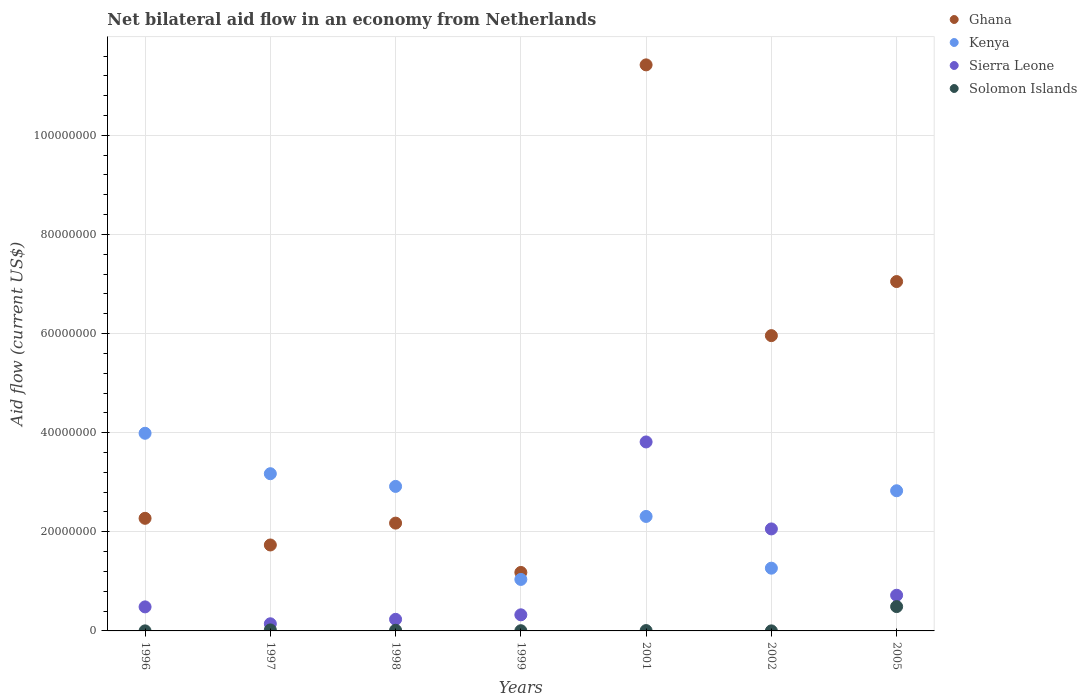How many different coloured dotlines are there?
Provide a short and direct response. 4. Is the number of dotlines equal to the number of legend labels?
Your answer should be very brief. Yes. What is the net bilateral aid flow in Ghana in 1999?
Your response must be concise. 1.18e+07. Across all years, what is the maximum net bilateral aid flow in Ghana?
Ensure brevity in your answer.  1.14e+08. Across all years, what is the minimum net bilateral aid flow in Sierra Leone?
Give a very brief answer. 1.44e+06. In which year was the net bilateral aid flow in Ghana maximum?
Your answer should be compact. 2001. In which year was the net bilateral aid flow in Solomon Islands minimum?
Make the answer very short. 1996. What is the total net bilateral aid flow in Solomon Islands in the graph?
Offer a terse response. 5.37e+06. What is the difference between the net bilateral aid flow in Ghana in 1996 and that in 2002?
Provide a succinct answer. -3.69e+07. What is the difference between the net bilateral aid flow in Ghana in 1998 and the net bilateral aid flow in Kenya in 1997?
Offer a very short reply. -9.97e+06. What is the average net bilateral aid flow in Solomon Islands per year?
Your answer should be very brief. 7.67e+05. In the year 2005, what is the difference between the net bilateral aid flow in Sierra Leone and net bilateral aid flow in Solomon Islands?
Give a very brief answer. 2.29e+06. In how many years, is the net bilateral aid flow in Sierra Leone greater than 40000000 US$?
Make the answer very short. 0. What is the ratio of the net bilateral aid flow in Sierra Leone in 1998 to that in 1999?
Your response must be concise. 0.72. What is the difference between the highest and the second highest net bilateral aid flow in Sierra Leone?
Provide a succinct answer. 1.76e+07. What is the difference between the highest and the lowest net bilateral aid flow in Solomon Islands?
Your answer should be very brief. 4.90e+06. Does the net bilateral aid flow in Kenya monotonically increase over the years?
Offer a very short reply. No. Is the net bilateral aid flow in Kenya strictly less than the net bilateral aid flow in Solomon Islands over the years?
Your response must be concise. No. How many dotlines are there?
Your answer should be very brief. 4. How many years are there in the graph?
Offer a terse response. 7. What is the difference between two consecutive major ticks on the Y-axis?
Keep it short and to the point. 2.00e+07. Are the values on the major ticks of Y-axis written in scientific E-notation?
Provide a succinct answer. No. Does the graph contain any zero values?
Your response must be concise. No. What is the title of the graph?
Ensure brevity in your answer.  Net bilateral aid flow in an economy from Netherlands. What is the label or title of the X-axis?
Your answer should be compact. Years. What is the Aid flow (current US$) of Ghana in 1996?
Ensure brevity in your answer.  2.27e+07. What is the Aid flow (current US$) of Kenya in 1996?
Keep it short and to the point. 3.99e+07. What is the Aid flow (current US$) in Sierra Leone in 1996?
Ensure brevity in your answer.  4.85e+06. What is the Aid flow (current US$) in Solomon Islands in 1996?
Provide a short and direct response. 10000. What is the Aid flow (current US$) of Ghana in 1997?
Your response must be concise. 1.73e+07. What is the Aid flow (current US$) in Kenya in 1997?
Offer a very short reply. 3.17e+07. What is the Aid flow (current US$) of Sierra Leone in 1997?
Provide a short and direct response. 1.44e+06. What is the Aid flow (current US$) in Ghana in 1998?
Your response must be concise. 2.18e+07. What is the Aid flow (current US$) in Kenya in 1998?
Provide a short and direct response. 2.92e+07. What is the Aid flow (current US$) of Sierra Leone in 1998?
Offer a very short reply. 2.34e+06. What is the Aid flow (current US$) of Solomon Islands in 1998?
Provide a short and direct response. 1.30e+05. What is the Aid flow (current US$) in Ghana in 1999?
Make the answer very short. 1.18e+07. What is the Aid flow (current US$) in Kenya in 1999?
Give a very brief answer. 1.04e+07. What is the Aid flow (current US$) in Sierra Leone in 1999?
Make the answer very short. 3.25e+06. What is the Aid flow (current US$) of Solomon Islands in 1999?
Give a very brief answer. 4.00e+04. What is the Aid flow (current US$) in Ghana in 2001?
Your answer should be compact. 1.14e+08. What is the Aid flow (current US$) of Kenya in 2001?
Give a very brief answer. 2.31e+07. What is the Aid flow (current US$) of Sierra Leone in 2001?
Give a very brief answer. 3.81e+07. What is the Aid flow (current US$) in Solomon Islands in 2001?
Make the answer very short. 7.00e+04. What is the Aid flow (current US$) of Ghana in 2002?
Offer a terse response. 5.96e+07. What is the Aid flow (current US$) of Kenya in 2002?
Your response must be concise. 1.27e+07. What is the Aid flow (current US$) of Sierra Leone in 2002?
Your answer should be very brief. 2.06e+07. What is the Aid flow (current US$) in Ghana in 2005?
Ensure brevity in your answer.  7.05e+07. What is the Aid flow (current US$) of Kenya in 2005?
Offer a terse response. 2.83e+07. What is the Aid flow (current US$) in Sierra Leone in 2005?
Offer a very short reply. 7.20e+06. What is the Aid flow (current US$) in Solomon Islands in 2005?
Offer a very short reply. 4.91e+06. Across all years, what is the maximum Aid flow (current US$) in Ghana?
Offer a very short reply. 1.14e+08. Across all years, what is the maximum Aid flow (current US$) of Kenya?
Your response must be concise. 3.99e+07. Across all years, what is the maximum Aid flow (current US$) in Sierra Leone?
Provide a succinct answer. 3.81e+07. Across all years, what is the maximum Aid flow (current US$) of Solomon Islands?
Offer a terse response. 4.91e+06. Across all years, what is the minimum Aid flow (current US$) in Ghana?
Offer a very short reply. 1.18e+07. Across all years, what is the minimum Aid flow (current US$) in Kenya?
Offer a terse response. 1.04e+07. Across all years, what is the minimum Aid flow (current US$) of Sierra Leone?
Offer a very short reply. 1.44e+06. Across all years, what is the minimum Aid flow (current US$) in Solomon Islands?
Keep it short and to the point. 10000. What is the total Aid flow (current US$) in Ghana in the graph?
Your response must be concise. 3.18e+08. What is the total Aid flow (current US$) in Kenya in the graph?
Give a very brief answer. 1.75e+08. What is the total Aid flow (current US$) in Sierra Leone in the graph?
Your response must be concise. 7.78e+07. What is the total Aid flow (current US$) of Solomon Islands in the graph?
Your answer should be compact. 5.37e+06. What is the difference between the Aid flow (current US$) in Ghana in 1996 and that in 1997?
Your answer should be very brief. 5.38e+06. What is the difference between the Aid flow (current US$) in Kenya in 1996 and that in 1997?
Provide a short and direct response. 8.16e+06. What is the difference between the Aid flow (current US$) in Sierra Leone in 1996 and that in 1997?
Your answer should be very brief. 3.41e+06. What is the difference between the Aid flow (current US$) of Solomon Islands in 1996 and that in 1997?
Provide a short and direct response. -1.90e+05. What is the difference between the Aid flow (current US$) in Ghana in 1996 and that in 1998?
Give a very brief answer. 9.70e+05. What is the difference between the Aid flow (current US$) of Kenya in 1996 and that in 1998?
Make the answer very short. 1.07e+07. What is the difference between the Aid flow (current US$) in Sierra Leone in 1996 and that in 1998?
Offer a very short reply. 2.51e+06. What is the difference between the Aid flow (current US$) of Solomon Islands in 1996 and that in 1998?
Your answer should be compact. -1.20e+05. What is the difference between the Aid flow (current US$) in Ghana in 1996 and that in 1999?
Your response must be concise. 1.09e+07. What is the difference between the Aid flow (current US$) in Kenya in 1996 and that in 1999?
Keep it short and to the point. 2.95e+07. What is the difference between the Aid flow (current US$) of Sierra Leone in 1996 and that in 1999?
Offer a very short reply. 1.60e+06. What is the difference between the Aid flow (current US$) in Solomon Islands in 1996 and that in 1999?
Offer a terse response. -3.00e+04. What is the difference between the Aid flow (current US$) in Ghana in 1996 and that in 2001?
Provide a short and direct response. -9.15e+07. What is the difference between the Aid flow (current US$) in Kenya in 1996 and that in 2001?
Ensure brevity in your answer.  1.68e+07. What is the difference between the Aid flow (current US$) of Sierra Leone in 1996 and that in 2001?
Offer a very short reply. -3.33e+07. What is the difference between the Aid flow (current US$) of Solomon Islands in 1996 and that in 2001?
Your answer should be compact. -6.00e+04. What is the difference between the Aid flow (current US$) of Ghana in 1996 and that in 2002?
Provide a succinct answer. -3.69e+07. What is the difference between the Aid flow (current US$) of Kenya in 1996 and that in 2002?
Make the answer very short. 2.72e+07. What is the difference between the Aid flow (current US$) in Sierra Leone in 1996 and that in 2002?
Ensure brevity in your answer.  -1.57e+07. What is the difference between the Aid flow (current US$) of Solomon Islands in 1996 and that in 2002?
Your response must be concise. 0. What is the difference between the Aid flow (current US$) of Ghana in 1996 and that in 2005?
Your response must be concise. -4.78e+07. What is the difference between the Aid flow (current US$) in Kenya in 1996 and that in 2005?
Your answer should be compact. 1.16e+07. What is the difference between the Aid flow (current US$) of Sierra Leone in 1996 and that in 2005?
Your answer should be very brief. -2.35e+06. What is the difference between the Aid flow (current US$) of Solomon Islands in 1996 and that in 2005?
Make the answer very short. -4.90e+06. What is the difference between the Aid flow (current US$) of Ghana in 1997 and that in 1998?
Make the answer very short. -4.41e+06. What is the difference between the Aid flow (current US$) in Kenya in 1997 and that in 1998?
Ensure brevity in your answer.  2.56e+06. What is the difference between the Aid flow (current US$) in Sierra Leone in 1997 and that in 1998?
Your response must be concise. -9.00e+05. What is the difference between the Aid flow (current US$) in Ghana in 1997 and that in 1999?
Offer a very short reply. 5.54e+06. What is the difference between the Aid flow (current US$) in Kenya in 1997 and that in 1999?
Your answer should be compact. 2.13e+07. What is the difference between the Aid flow (current US$) of Sierra Leone in 1997 and that in 1999?
Provide a short and direct response. -1.81e+06. What is the difference between the Aid flow (current US$) in Solomon Islands in 1997 and that in 1999?
Your answer should be very brief. 1.60e+05. What is the difference between the Aid flow (current US$) of Ghana in 1997 and that in 2001?
Offer a very short reply. -9.69e+07. What is the difference between the Aid flow (current US$) in Kenya in 1997 and that in 2001?
Give a very brief answer. 8.62e+06. What is the difference between the Aid flow (current US$) of Sierra Leone in 1997 and that in 2001?
Make the answer very short. -3.67e+07. What is the difference between the Aid flow (current US$) in Ghana in 1997 and that in 2002?
Offer a very short reply. -4.22e+07. What is the difference between the Aid flow (current US$) of Kenya in 1997 and that in 2002?
Your answer should be compact. 1.91e+07. What is the difference between the Aid flow (current US$) of Sierra Leone in 1997 and that in 2002?
Keep it short and to the point. -1.91e+07. What is the difference between the Aid flow (current US$) in Ghana in 1997 and that in 2005?
Offer a terse response. -5.32e+07. What is the difference between the Aid flow (current US$) in Kenya in 1997 and that in 2005?
Provide a succinct answer. 3.44e+06. What is the difference between the Aid flow (current US$) in Sierra Leone in 1997 and that in 2005?
Your answer should be very brief. -5.76e+06. What is the difference between the Aid flow (current US$) in Solomon Islands in 1997 and that in 2005?
Give a very brief answer. -4.71e+06. What is the difference between the Aid flow (current US$) in Ghana in 1998 and that in 1999?
Your answer should be compact. 9.95e+06. What is the difference between the Aid flow (current US$) of Kenya in 1998 and that in 1999?
Offer a terse response. 1.88e+07. What is the difference between the Aid flow (current US$) in Sierra Leone in 1998 and that in 1999?
Provide a short and direct response. -9.10e+05. What is the difference between the Aid flow (current US$) in Solomon Islands in 1998 and that in 1999?
Your answer should be compact. 9.00e+04. What is the difference between the Aid flow (current US$) of Ghana in 1998 and that in 2001?
Make the answer very short. -9.25e+07. What is the difference between the Aid flow (current US$) in Kenya in 1998 and that in 2001?
Provide a short and direct response. 6.06e+06. What is the difference between the Aid flow (current US$) in Sierra Leone in 1998 and that in 2001?
Provide a succinct answer. -3.58e+07. What is the difference between the Aid flow (current US$) of Solomon Islands in 1998 and that in 2001?
Make the answer very short. 6.00e+04. What is the difference between the Aid flow (current US$) in Ghana in 1998 and that in 2002?
Make the answer very short. -3.78e+07. What is the difference between the Aid flow (current US$) in Kenya in 1998 and that in 2002?
Offer a very short reply. 1.65e+07. What is the difference between the Aid flow (current US$) of Sierra Leone in 1998 and that in 2002?
Your response must be concise. -1.82e+07. What is the difference between the Aid flow (current US$) of Solomon Islands in 1998 and that in 2002?
Provide a short and direct response. 1.20e+05. What is the difference between the Aid flow (current US$) in Ghana in 1998 and that in 2005?
Keep it short and to the point. -4.87e+07. What is the difference between the Aid flow (current US$) in Kenya in 1998 and that in 2005?
Your response must be concise. 8.80e+05. What is the difference between the Aid flow (current US$) of Sierra Leone in 1998 and that in 2005?
Make the answer very short. -4.86e+06. What is the difference between the Aid flow (current US$) of Solomon Islands in 1998 and that in 2005?
Your answer should be compact. -4.78e+06. What is the difference between the Aid flow (current US$) in Ghana in 1999 and that in 2001?
Offer a very short reply. -1.02e+08. What is the difference between the Aid flow (current US$) of Kenya in 1999 and that in 2001?
Ensure brevity in your answer.  -1.27e+07. What is the difference between the Aid flow (current US$) in Sierra Leone in 1999 and that in 2001?
Make the answer very short. -3.49e+07. What is the difference between the Aid flow (current US$) in Ghana in 1999 and that in 2002?
Your answer should be very brief. -4.78e+07. What is the difference between the Aid flow (current US$) of Kenya in 1999 and that in 2002?
Provide a succinct answer. -2.27e+06. What is the difference between the Aid flow (current US$) of Sierra Leone in 1999 and that in 2002?
Ensure brevity in your answer.  -1.73e+07. What is the difference between the Aid flow (current US$) in Solomon Islands in 1999 and that in 2002?
Provide a succinct answer. 3.00e+04. What is the difference between the Aid flow (current US$) in Ghana in 1999 and that in 2005?
Your answer should be very brief. -5.87e+07. What is the difference between the Aid flow (current US$) of Kenya in 1999 and that in 2005?
Keep it short and to the point. -1.79e+07. What is the difference between the Aid flow (current US$) in Sierra Leone in 1999 and that in 2005?
Your answer should be very brief. -3.95e+06. What is the difference between the Aid flow (current US$) of Solomon Islands in 1999 and that in 2005?
Offer a terse response. -4.87e+06. What is the difference between the Aid flow (current US$) in Ghana in 2001 and that in 2002?
Make the answer very short. 5.46e+07. What is the difference between the Aid flow (current US$) of Kenya in 2001 and that in 2002?
Your answer should be compact. 1.04e+07. What is the difference between the Aid flow (current US$) in Sierra Leone in 2001 and that in 2002?
Make the answer very short. 1.76e+07. What is the difference between the Aid flow (current US$) in Solomon Islands in 2001 and that in 2002?
Provide a succinct answer. 6.00e+04. What is the difference between the Aid flow (current US$) of Ghana in 2001 and that in 2005?
Your response must be concise. 4.37e+07. What is the difference between the Aid flow (current US$) in Kenya in 2001 and that in 2005?
Your answer should be very brief. -5.18e+06. What is the difference between the Aid flow (current US$) of Sierra Leone in 2001 and that in 2005?
Provide a succinct answer. 3.09e+07. What is the difference between the Aid flow (current US$) of Solomon Islands in 2001 and that in 2005?
Offer a very short reply. -4.84e+06. What is the difference between the Aid flow (current US$) of Ghana in 2002 and that in 2005?
Offer a very short reply. -1.09e+07. What is the difference between the Aid flow (current US$) of Kenya in 2002 and that in 2005?
Make the answer very short. -1.56e+07. What is the difference between the Aid flow (current US$) in Sierra Leone in 2002 and that in 2005?
Your answer should be very brief. 1.34e+07. What is the difference between the Aid flow (current US$) in Solomon Islands in 2002 and that in 2005?
Ensure brevity in your answer.  -4.90e+06. What is the difference between the Aid flow (current US$) of Ghana in 1996 and the Aid flow (current US$) of Kenya in 1997?
Provide a succinct answer. -9.00e+06. What is the difference between the Aid flow (current US$) of Ghana in 1996 and the Aid flow (current US$) of Sierra Leone in 1997?
Your answer should be very brief. 2.13e+07. What is the difference between the Aid flow (current US$) of Ghana in 1996 and the Aid flow (current US$) of Solomon Islands in 1997?
Provide a succinct answer. 2.25e+07. What is the difference between the Aid flow (current US$) in Kenya in 1996 and the Aid flow (current US$) in Sierra Leone in 1997?
Keep it short and to the point. 3.84e+07. What is the difference between the Aid flow (current US$) of Kenya in 1996 and the Aid flow (current US$) of Solomon Islands in 1997?
Your answer should be very brief. 3.97e+07. What is the difference between the Aid flow (current US$) of Sierra Leone in 1996 and the Aid flow (current US$) of Solomon Islands in 1997?
Keep it short and to the point. 4.65e+06. What is the difference between the Aid flow (current US$) in Ghana in 1996 and the Aid flow (current US$) in Kenya in 1998?
Offer a terse response. -6.44e+06. What is the difference between the Aid flow (current US$) of Ghana in 1996 and the Aid flow (current US$) of Sierra Leone in 1998?
Provide a short and direct response. 2.04e+07. What is the difference between the Aid flow (current US$) in Ghana in 1996 and the Aid flow (current US$) in Solomon Islands in 1998?
Provide a succinct answer. 2.26e+07. What is the difference between the Aid flow (current US$) in Kenya in 1996 and the Aid flow (current US$) in Sierra Leone in 1998?
Your answer should be very brief. 3.75e+07. What is the difference between the Aid flow (current US$) of Kenya in 1996 and the Aid flow (current US$) of Solomon Islands in 1998?
Your response must be concise. 3.98e+07. What is the difference between the Aid flow (current US$) in Sierra Leone in 1996 and the Aid flow (current US$) in Solomon Islands in 1998?
Give a very brief answer. 4.72e+06. What is the difference between the Aid flow (current US$) in Ghana in 1996 and the Aid flow (current US$) in Kenya in 1999?
Offer a terse response. 1.23e+07. What is the difference between the Aid flow (current US$) in Ghana in 1996 and the Aid flow (current US$) in Sierra Leone in 1999?
Make the answer very short. 1.95e+07. What is the difference between the Aid flow (current US$) of Ghana in 1996 and the Aid flow (current US$) of Solomon Islands in 1999?
Offer a terse response. 2.27e+07. What is the difference between the Aid flow (current US$) in Kenya in 1996 and the Aid flow (current US$) in Sierra Leone in 1999?
Offer a very short reply. 3.66e+07. What is the difference between the Aid flow (current US$) in Kenya in 1996 and the Aid flow (current US$) in Solomon Islands in 1999?
Provide a short and direct response. 3.98e+07. What is the difference between the Aid flow (current US$) of Sierra Leone in 1996 and the Aid flow (current US$) of Solomon Islands in 1999?
Offer a very short reply. 4.81e+06. What is the difference between the Aid flow (current US$) in Ghana in 1996 and the Aid flow (current US$) in Kenya in 2001?
Your answer should be very brief. -3.80e+05. What is the difference between the Aid flow (current US$) of Ghana in 1996 and the Aid flow (current US$) of Sierra Leone in 2001?
Give a very brief answer. -1.54e+07. What is the difference between the Aid flow (current US$) of Ghana in 1996 and the Aid flow (current US$) of Solomon Islands in 2001?
Offer a very short reply. 2.26e+07. What is the difference between the Aid flow (current US$) in Kenya in 1996 and the Aid flow (current US$) in Sierra Leone in 2001?
Your answer should be very brief. 1.75e+06. What is the difference between the Aid flow (current US$) in Kenya in 1996 and the Aid flow (current US$) in Solomon Islands in 2001?
Ensure brevity in your answer.  3.98e+07. What is the difference between the Aid flow (current US$) of Sierra Leone in 1996 and the Aid flow (current US$) of Solomon Islands in 2001?
Ensure brevity in your answer.  4.78e+06. What is the difference between the Aid flow (current US$) in Ghana in 1996 and the Aid flow (current US$) in Kenya in 2002?
Make the answer very short. 1.01e+07. What is the difference between the Aid flow (current US$) in Ghana in 1996 and the Aid flow (current US$) in Sierra Leone in 2002?
Make the answer very short. 2.14e+06. What is the difference between the Aid flow (current US$) of Ghana in 1996 and the Aid flow (current US$) of Solomon Islands in 2002?
Provide a short and direct response. 2.27e+07. What is the difference between the Aid flow (current US$) in Kenya in 1996 and the Aid flow (current US$) in Sierra Leone in 2002?
Your answer should be very brief. 1.93e+07. What is the difference between the Aid flow (current US$) in Kenya in 1996 and the Aid flow (current US$) in Solomon Islands in 2002?
Your response must be concise. 3.99e+07. What is the difference between the Aid flow (current US$) of Sierra Leone in 1996 and the Aid flow (current US$) of Solomon Islands in 2002?
Your answer should be compact. 4.84e+06. What is the difference between the Aid flow (current US$) in Ghana in 1996 and the Aid flow (current US$) in Kenya in 2005?
Make the answer very short. -5.56e+06. What is the difference between the Aid flow (current US$) in Ghana in 1996 and the Aid flow (current US$) in Sierra Leone in 2005?
Keep it short and to the point. 1.55e+07. What is the difference between the Aid flow (current US$) of Ghana in 1996 and the Aid flow (current US$) of Solomon Islands in 2005?
Your response must be concise. 1.78e+07. What is the difference between the Aid flow (current US$) of Kenya in 1996 and the Aid flow (current US$) of Sierra Leone in 2005?
Your answer should be very brief. 3.27e+07. What is the difference between the Aid flow (current US$) of Kenya in 1996 and the Aid flow (current US$) of Solomon Islands in 2005?
Make the answer very short. 3.50e+07. What is the difference between the Aid flow (current US$) in Ghana in 1997 and the Aid flow (current US$) in Kenya in 1998?
Your answer should be compact. -1.18e+07. What is the difference between the Aid flow (current US$) of Ghana in 1997 and the Aid flow (current US$) of Sierra Leone in 1998?
Keep it short and to the point. 1.50e+07. What is the difference between the Aid flow (current US$) in Ghana in 1997 and the Aid flow (current US$) in Solomon Islands in 1998?
Your answer should be very brief. 1.72e+07. What is the difference between the Aid flow (current US$) of Kenya in 1997 and the Aid flow (current US$) of Sierra Leone in 1998?
Offer a terse response. 2.94e+07. What is the difference between the Aid flow (current US$) of Kenya in 1997 and the Aid flow (current US$) of Solomon Islands in 1998?
Your answer should be compact. 3.16e+07. What is the difference between the Aid flow (current US$) of Sierra Leone in 1997 and the Aid flow (current US$) of Solomon Islands in 1998?
Offer a terse response. 1.31e+06. What is the difference between the Aid flow (current US$) in Ghana in 1997 and the Aid flow (current US$) in Kenya in 1999?
Give a very brief answer. 6.95e+06. What is the difference between the Aid flow (current US$) of Ghana in 1997 and the Aid flow (current US$) of Sierra Leone in 1999?
Provide a short and direct response. 1.41e+07. What is the difference between the Aid flow (current US$) of Ghana in 1997 and the Aid flow (current US$) of Solomon Islands in 1999?
Your answer should be very brief. 1.73e+07. What is the difference between the Aid flow (current US$) in Kenya in 1997 and the Aid flow (current US$) in Sierra Leone in 1999?
Keep it short and to the point. 2.85e+07. What is the difference between the Aid flow (current US$) of Kenya in 1997 and the Aid flow (current US$) of Solomon Islands in 1999?
Offer a terse response. 3.17e+07. What is the difference between the Aid flow (current US$) of Sierra Leone in 1997 and the Aid flow (current US$) of Solomon Islands in 1999?
Your answer should be very brief. 1.40e+06. What is the difference between the Aid flow (current US$) of Ghana in 1997 and the Aid flow (current US$) of Kenya in 2001?
Offer a very short reply. -5.76e+06. What is the difference between the Aid flow (current US$) of Ghana in 1997 and the Aid flow (current US$) of Sierra Leone in 2001?
Provide a short and direct response. -2.08e+07. What is the difference between the Aid flow (current US$) of Ghana in 1997 and the Aid flow (current US$) of Solomon Islands in 2001?
Ensure brevity in your answer.  1.73e+07. What is the difference between the Aid flow (current US$) in Kenya in 1997 and the Aid flow (current US$) in Sierra Leone in 2001?
Provide a succinct answer. -6.41e+06. What is the difference between the Aid flow (current US$) in Kenya in 1997 and the Aid flow (current US$) in Solomon Islands in 2001?
Your answer should be compact. 3.16e+07. What is the difference between the Aid flow (current US$) in Sierra Leone in 1997 and the Aid flow (current US$) in Solomon Islands in 2001?
Your answer should be very brief. 1.37e+06. What is the difference between the Aid flow (current US$) of Ghana in 1997 and the Aid flow (current US$) of Kenya in 2002?
Offer a terse response. 4.68e+06. What is the difference between the Aid flow (current US$) in Ghana in 1997 and the Aid flow (current US$) in Sierra Leone in 2002?
Make the answer very short. -3.24e+06. What is the difference between the Aid flow (current US$) of Ghana in 1997 and the Aid flow (current US$) of Solomon Islands in 2002?
Your response must be concise. 1.73e+07. What is the difference between the Aid flow (current US$) in Kenya in 1997 and the Aid flow (current US$) in Sierra Leone in 2002?
Your answer should be compact. 1.11e+07. What is the difference between the Aid flow (current US$) of Kenya in 1997 and the Aid flow (current US$) of Solomon Islands in 2002?
Ensure brevity in your answer.  3.17e+07. What is the difference between the Aid flow (current US$) in Sierra Leone in 1997 and the Aid flow (current US$) in Solomon Islands in 2002?
Make the answer very short. 1.43e+06. What is the difference between the Aid flow (current US$) of Ghana in 1997 and the Aid flow (current US$) of Kenya in 2005?
Offer a terse response. -1.09e+07. What is the difference between the Aid flow (current US$) of Ghana in 1997 and the Aid flow (current US$) of Sierra Leone in 2005?
Make the answer very short. 1.01e+07. What is the difference between the Aid flow (current US$) of Ghana in 1997 and the Aid flow (current US$) of Solomon Islands in 2005?
Ensure brevity in your answer.  1.24e+07. What is the difference between the Aid flow (current US$) in Kenya in 1997 and the Aid flow (current US$) in Sierra Leone in 2005?
Make the answer very short. 2.45e+07. What is the difference between the Aid flow (current US$) in Kenya in 1997 and the Aid flow (current US$) in Solomon Islands in 2005?
Keep it short and to the point. 2.68e+07. What is the difference between the Aid flow (current US$) of Sierra Leone in 1997 and the Aid flow (current US$) of Solomon Islands in 2005?
Provide a short and direct response. -3.47e+06. What is the difference between the Aid flow (current US$) in Ghana in 1998 and the Aid flow (current US$) in Kenya in 1999?
Offer a very short reply. 1.14e+07. What is the difference between the Aid flow (current US$) of Ghana in 1998 and the Aid flow (current US$) of Sierra Leone in 1999?
Offer a terse response. 1.85e+07. What is the difference between the Aid flow (current US$) of Ghana in 1998 and the Aid flow (current US$) of Solomon Islands in 1999?
Give a very brief answer. 2.17e+07. What is the difference between the Aid flow (current US$) in Kenya in 1998 and the Aid flow (current US$) in Sierra Leone in 1999?
Ensure brevity in your answer.  2.59e+07. What is the difference between the Aid flow (current US$) of Kenya in 1998 and the Aid flow (current US$) of Solomon Islands in 1999?
Give a very brief answer. 2.91e+07. What is the difference between the Aid flow (current US$) in Sierra Leone in 1998 and the Aid flow (current US$) in Solomon Islands in 1999?
Make the answer very short. 2.30e+06. What is the difference between the Aid flow (current US$) in Ghana in 1998 and the Aid flow (current US$) in Kenya in 2001?
Offer a terse response. -1.35e+06. What is the difference between the Aid flow (current US$) of Ghana in 1998 and the Aid flow (current US$) of Sierra Leone in 2001?
Provide a short and direct response. -1.64e+07. What is the difference between the Aid flow (current US$) in Ghana in 1998 and the Aid flow (current US$) in Solomon Islands in 2001?
Offer a terse response. 2.17e+07. What is the difference between the Aid flow (current US$) of Kenya in 1998 and the Aid flow (current US$) of Sierra Leone in 2001?
Your response must be concise. -8.97e+06. What is the difference between the Aid flow (current US$) in Kenya in 1998 and the Aid flow (current US$) in Solomon Islands in 2001?
Offer a terse response. 2.91e+07. What is the difference between the Aid flow (current US$) of Sierra Leone in 1998 and the Aid flow (current US$) of Solomon Islands in 2001?
Make the answer very short. 2.27e+06. What is the difference between the Aid flow (current US$) in Ghana in 1998 and the Aid flow (current US$) in Kenya in 2002?
Keep it short and to the point. 9.09e+06. What is the difference between the Aid flow (current US$) in Ghana in 1998 and the Aid flow (current US$) in Sierra Leone in 2002?
Keep it short and to the point. 1.17e+06. What is the difference between the Aid flow (current US$) in Ghana in 1998 and the Aid flow (current US$) in Solomon Islands in 2002?
Your answer should be compact. 2.17e+07. What is the difference between the Aid flow (current US$) in Kenya in 1998 and the Aid flow (current US$) in Sierra Leone in 2002?
Your answer should be very brief. 8.58e+06. What is the difference between the Aid flow (current US$) of Kenya in 1998 and the Aid flow (current US$) of Solomon Islands in 2002?
Your answer should be compact. 2.92e+07. What is the difference between the Aid flow (current US$) in Sierra Leone in 1998 and the Aid flow (current US$) in Solomon Islands in 2002?
Offer a terse response. 2.33e+06. What is the difference between the Aid flow (current US$) in Ghana in 1998 and the Aid flow (current US$) in Kenya in 2005?
Offer a very short reply. -6.53e+06. What is the difference between the Aid flow (current US$) in Ghana in 1998 and the Aid flow (current US$) in Sierra Leone in 2005?
Keep it short and to the point. 1.46e+07. What is the difference between the Aid flow (current US$) in Ghana in 1998 and the Aid flow (current US$) in Solomon Islands in 2005?
Your response must be concise. 1.68e+07. What is the difference between the Aid flow (current US$) of Kenya in 1998 and the Aid flow (current US$) of Sierra Leone in 2005?
Make the answer very short. 2.20e+07. What is the difference between the Aid flow (current US$) of Kenya in 1998 and the Aid flow (current US$) of Solomon Islands in 2005?
Offer a very short reply. 2.42e+07. What is the difference between the Aid flow (current US$) of Sierra Leone in 1998 and the Aid flow (current US$) of Solomon Islands in 2005?
Provide a short and direct response. -2.57e+06. What is the difference between the Aid flow (current US$) in Ghana in 1999 and the Aid flow (current US$) in Kenya in 2001?
Your answer should be very brief. -1.13e+07. What is the difference between the Aid flow (current US$) of Ghana in 1999 and the Aid flow (current US$) of Sierra Leone in 2001?
Your answer should be very brief. -2.63e+07. What is the difference between the Aid flow (current US$) in Ghana in 1999 and the Aid flow (current US$) in Solomon Islands in 2001?
Ensure brevity in your answer.  1.17e+07. What is the difference between the Aid flow (current US$) of Kenya in 1999 and the Aid flow (current US$) of Sierra Leone in 2001?
Offer a terse response. -2.77e+07. What is the difference between the Aid flow (current US$) of Kenya in 1999 and the Aid flow (current US$) of Solomon Islands in 2001?
Provide a short and direct response. 1.03e+07. What is the difference between the Aid flow (current US$) of Sierra Leone in 1999 and the Aid flow (current US$) of Solomon Islands in 2001?
Offer a terse response. 3.18e+06. What is the difference between the Aid flow (current US$) of Ghana in 1999 and the Aid flow (current US$) of Kenya in 2002?
Offer a terse response. -8.60e+05. What is the difference between the Aid flow (current US$) in Ghana in 1999 and the Aid flow (current US$) in Sierra Leone in 2002?
Ensure brevity in your answer.  -8.78e+06. What is the difference between the Aid flow (current US$) in Ghana in 1999 and the Aid flow (current US$) in Solomon Islands in 2002?
Offer a very short reply. 1.18e+07. What is the difference between the Aid flow (current US$) of Kenya in 1999 and the Aid flow (current US$) of Sierra Leone in 2002?
Ensure brevity in your answer.  -1.02e+07. What is the difference between the Aid flow (current US$) of Kenya in 1999 and the Aid flow (current US$) of Solomon Islands in 2002?
Offer a very short reply. 1.04e+07. What is the difference between the Aid flow (current US$) of Sierra Leone in 1999 and the Aid flow (current US$) of Solomon Islands in 2002?
Give a very brief answer. 3.24e+06. What is the difference between the Aid flow (current US$) of Ghana in 1999 and the Aid flow (current US$) of Kenya in 2005?
Offer a terse response. -1.65e+07. What is the difference between the Aid flow (current US$) of Ghana in 1999 and the Aid flow (current US$) of Sierra Leone in 2005?
Ensure brevity in your answer.  4.60e+06. What is the difference between the Aid flow (current US$) in Ghana in 1999 and the Aid flow (current US$) in Solomon Islands in 2005?
Provide a short and direct response. 6.89e+06. What is the difference between the Aid flow (current US$) of Kenya in 1999 and the Aid flow (current US$) of Sierra Leone in 2005?
Ensure brevity in your answer.  3.19e+06. What is the difference between the Aid flow (current US$) in Kenya in 1999 and the Aid flow (current US$) in Solomon Islands in 2005?
Make the answer very short. 5.48e+06. What is the difference between the Aid flow (current US$) in Sierra Leone in 1999 and the Aid flow (current US$) in Solomon Islands in 2005?
Keep it short and to the point. -1.66e+06. What is the difference between the Aid flow (current US$) of Ghana in 2001 and the Aid flow (current US$) of Kenya in 2002?
Your answer should be compact. 1.02e+08. What is the difference between the Aid flow (current US$) in Ghana in 2001 and the Aid flow (current US$) in Sierra Leone in 2002?
Provide a short and direct response. 9.36e+07. What is the difference between the Aid flow (current US$) in Ghana in 2001 and the Aid flow (current US$) in Solomon Islands in 2002?
Give a very brief answer. 1.14e+08. What is the difference between the Aid flow (current US$) in Kenya in 2001 and the Aid flow (current US$) in Sierra Leone in 2002?
Provide a succinct answer. 2.52e+06. What is the difference between the Aid flow (current US$) in Kenya in 2001 and the Aid flow (current US$) in Solomon Islands in 2002?
Your answer should be very brief. 2.31e+07. What is the difference between the Aid flow (current US$) of Sierra Leone in 2001 and the Aid flow (current US$) of Solomon Islands in 2002?
Provide a succinct answer. 3.81e+07. What is the difference between the Aid flow (current US$) in Ghana in 2001 and the Aid flow (current US$) in Kenya in 2005?
Provide a succinct answer. 8.59e+07. What is the difference between the Aid flow (current US$) in Ghana in 2001 and the Aid flow (current US$) in Sierra Leone in 2005?
Provide a short and direct response. 1.07e+08. What is the difference between the Aid flow (current US$) of Ghana in 2001 and the Aid flow (current US$) of Solomon Islands in 2005?
Your response must be concise. 1.09e+08. What is the difference between the Aid flow (current US$) in Kenya in 2001 and the Aid flow (current US$) in Sierra Leone in 2005?
Give a very brief answer. 1.59e+07. What is the difference between the Aid flow (current US$) of Kenya in 2001 and the Aid flow (current US$) of Solomon Islands in 2005?
Offer a terse response. 1.82e+07. What is the difference between the Aid flow (current US$) of Sierra Leone in 2001 and the Aid flow (current US$) of Solomon Islands in 2005?
Your answer should be very brief. 3.32e+07. What is the difference between the Aid flow (current US$) of Ghana in 2002 and the Aid flow (current US$) of Kenya in 2005?
Keep it short and to the point. 3.13e+07. What is the difference between the Aid flow (current US$) in Ghana in 2002 and the Aid flow (current US$) in Sierra Leone in 2005?
Your response must be concise. 5.24e+07. What is the difference between the Aid flow (current US$) of Ghana in 2002 and the Aid flow (current US$) of Solomon Islands in 2005?
Your answer should be very brief. 5.47e+07. What is the difference between the Aid flow (current US$) in Kenya in 2002 and the Aid flow (current US$) in Sierra Leone in 2005?
Offer a very short reply. 5.46e+06. What is the difference between the Aid flow (current US$) in Kenya in 2002 and the Aid flow (current US$) in Solomon Islands in 2005?
Make the answer very short. 7.75e+06. What is the difference between the Aid flow (current US$) of Sierra Leone in 2002 and the Aid flow (current US$) of Solomon Islands in 2005?
Ensure brevity in your answer.  1.57e+07. What is the average Aid flow (current US$) of Ghana per year?
Ensure brevity in your answer.  4.54e+07. What is the average Aid flow (current US$) in Kenya per year?
Your answer should be compact. 2.50e+07. What is the average Aid flow (current US$) in Sierra Leone per year?
Give a very brief answer. 1.11e+07. What is the average Aid flow (current US$) of Solomon Islands per year?
Keep it short and to the point. 7.67e+05. In the year 1996, what is the difference between the Aid flow (current US$) of Ghana and Aid flow (current US$) of Kenya?
Give a very brief answer. -1.72e+07. In the year 1996, what is the difference between the Aid flow (current US$) in Ghana and Aid flow (current US$) in Sierra Leone?
Make the answer very short. 1.79e+07. In the year 1996, what is the difference between the Aid flow (current US$) in Ghana and Aid flow (current US$) in Solomon Islands?
Your response must be concise. 2.27e+07. In the year 1996, what is the difference between the Aid flow (current US$) in Kenya and Aid flow (current US$) in Sierra Leone?
Your answer should be very brief. 3.50e+07. In the year 1996, what is the difference between the Aid flow (current US$) of Kenya and Aid flow (current US$) of Solomon Islands?
Your answer should be very brief. 3.99e+07. In the year 1996, what is the difference between the Aid flow (current US$) of Sierra Leone and Aid flow (current US$) of Solomon Islands?
Make the answer very short. 4.84e+06. In the year 1997, what is the difference between the Aid flow (current US$) in Ghana and Aid flow (current US$) in Kenya?
Give a very brief answer. -1.44e+07. In the year 1997, what is the difference between the Aid flow (current US$) of Ghana and Aid flow (current US$) of Sierra Leone?
Give a very brief answer. 1.59e+07. In the year 1997, what is the difference between the Aid flow (current US$) of Ghana and Aid flow (current US$) of Solomon Islands?
Your response must be concise. 1.71e+07. In the year 1997, what is the difference between the Aid flow (current US$) of Kenya and Aid flow (current US$) of Sierra Leone?
Your response must be concise. 3.03e+07. In the year 1997, what is the difference between the Aid flow (current US$) in Kenya and Aid flow (current US$) in Solomon Islands?
Your answer should be very brief. 3.15e+07. In the year 1997, what is the difference between the Aid flow (current US$) in Sierra Leone and Aid flow (current US$) in Solomon Islands?
Ensure brevity in your answer.  1.24e+06. In the year 1998, what is the difference between the Aid flow (current US$) in Ghana and Aid flow (current US$) in Kenya?
Your answer should be compact. -7.41e+06. In the year 1998, what is the difference between the Aid flow (current US$) in Ghana and Aid flow (current US$) in Sierra Leone?
Make the answer very short. 1.94e+07. In the year 1998, what is the difference between the Aid flow (current US$) of Ghana and Aid flow (current US$) of Solomon Islands?
Provide a short and direct response. 2.16e+07. In the year 1998, what is the difference between the Aid flow (current US$) in Kenya and Aid flow (current US$) in Sierra Leone?
Your answer should be compact. 2.68e+07. In the year 1998, what is the difference between the Aid flow (current US$) in Kenya and Aid flow (current US$) in Solomon Islands?
Provide a succinct answer. 2.90e+07. In the year 1998, what is the difference between the Aid flow (current US$) in Sierra Leone and Aid flow (current US$) in Solomon Islands?
Provide a succinct answer. 2.21e+06. In the year 1999, what is the difference between the Aid flow (current US$) of Ghana and Aid flow (current US$) of Kenya?
Keep it short and to the point. 1.41e+06. In the year 1999, what is the difference between the Aid flow (current US$) of Ghana and Aid flow (current US$) of Sierra Leone?
Provide a short and direct response. 8.55e+06. In the year 1999, what is the difference between the Aid flow (current US$) in Ghana and Aid flow (current US$) in Solomon Islands?
Give a very brief answer. 1.18e+07. In the year 1999, what is the difference between the Aid flow (current US$) of Kenya and Aid flow (current US$) of Sierra Leone?
Offer a terse response. 7.14e+06. In the year 1999, what is the difference between the Aid flow (current US$) of Kenya and Aid flow (current US$) of Solomon Islands?
Provide a short and direct response. 1.04e+07. In the year 1999, what is the difference between the Aid flow (current US$) in Sierra Leone and Aid flow (current US$) in Solomon Islands?
Provide a short and direct response. 3.21e+06. In the year 2001, what is the difference between the Aid flow (current US$) in Ghana and Aid flow (current US$) in Kenya?
Give a very brief answer. 9.11e+07. In the year 2001, what is the difference between the Aid flow (current US$) in Ghana and Aid flow (current US$) in Sierra Leone?
Keep it short and to the point. 7.61e+07. In the year 2001, what is the difference between the Aid flow (current US$) in Ghana and Aid flow (current US$) in Solomon Islands?
Ensure brevity in your answer.  1.14e+08. In the year 2001, what is the difference between the Aid flow (current US$) in Kenya and Aid flow (current US$) in Sierra Leone?
Give a very brief answer. -1.50e+07. In the year 2001, what is the difference between the Aid flow (current US$) in Kenya and Aid flow (current US$) in Solomon Islands?
Offer a terse response. 2.30e+07. In the year 2001, what is the difference between the Aid flow (current US$) in Sierra Leone and Aid flow (current US$) in Solomon Islands?
Ensure brevity in your answer.  3.81e+07. In the year 2002, what is the difference between the Aid flow (current US$) of Ghana and Aid flow (current US$) of Kenya?
Make the answer very short. 4.69e+07. In the year 2002, what is the difference between the Aid flow (current US$) of Ghana and Aid flow (current US$) of Sierra Leone?
Your answer should be very brief. 3.90e+07. In the year 2002, what is the difference between the Aid flow (current US$) of Ghana and Aid flow (current US$) of Solomon Islands?
Ensure brevity in your answer.  5.96e+07. In the year 2002, what is the difference between the Aid flow (current US$) in Kenya and Aid flow (current US$) in Sierra Leone?
Your response must be concise. -7.92e+06. In the year 2002, what is the difference between the Aid flow (current US$) of Kenya and Aid flow (current US$) of Solomon Islands?
Your answer should be compact. 1.26e+07. In the year 2002, what is the difference between the Aid flow (current US$) of Sierra Leone and Aid flow (current US$) of Solomon Islands?
Your answer should be compact. 2.06e+07. In the year 2005, what is the difference between the Aid flow (current US$) of Ghana and Aid flow (current US$) of Kenya?
Your answer should be very brief. 4.22e+07. In the year 2005, what is the difference between the Aid flow (current US$) of Ghana and Aid flow (current US$) of Sierra Leone?
Keep it short and to the point. 6.33e+07. In the year 2005, what is the difference between the Aid flow (current US$) of Ghana and Aid flow (current US$) of Solomon Islands?
Your response must be concise. 6.56e+07. In the year 2005, what is the difference between the Aid flow (current US$) in Kenya and Aid flow (current US$) in Sierra Leone?
Your answer should be compact. 2.11e+07. In the year 2005, what is the difference between the Aid flow (current US$) in Kenya and Aid flow (current US$) in Solomon Islands?
Offer a very short reply. 2.34e+07. In the year 2005, what is the difference between the Aid flow (current US$) of Sierra Leone and Aid flow (current US$) of Solomon Islands?
Keep it short and to the point. 2.29e+06. What is the ratio of the Aid flow (current US$) in Ghana in 1996 to that in 1997?
Make the answer very short. 1.31. What is the ratio of the Aid flow (current US$) of Kenya in 1996 to that in 1997?
Ensure brevity in your answer.  1.26. What is the ratio of the Aid flow (current US$) of Sierra Leone in 1996 to that in 1997?
Your answer should be compact. 3.37. What is the ratio of the Aid flow (current US$) of Solomon Islands in 1996 to that in 1997?
Offer a very short reply. 0.05. What is the ratio of the Aid flow (current US$) in Ghana in 1996 to that in 1998?
Offer a terse response. 1.04. What is the ratio of the Aid flow (current US$) in Kenya in 1996 to that in 1998?
Offer a terse response. 1.37. What is the ratio of the Aid flow (current US$) of Sierra Leone in 1996 to that in 1998?
Your answer should be compact. 2.07. What is the ratio of the Aid flow (current US$) of Solomon Islands in 1996 to that in 1998?
Provide a short and direct response. 0.08. What is the ratio of the Aid flow (current US$) in Ghana in 1996 to that in 1999?
Keep it short and to the point. 1.93. What is the ratio of the Aid flow (current US$) of Kenya in 1996 to that in 1999?
Your response must be concise. 3.84. What is the ratio of the Aid flow (current US$) of Sierra Leone in 1996 to that in 1999?
Offer a very short reply. 1.49. What is the ratio of the Aid flow (current US$) in Ghana in 1996 to that in 2001?
Make the answer very short. 0.2. What is the ratio of the Aid flow (current US$) in Kenya in 1996 to that in 2001?
Provide a short and direct response. 1.73. What is the ratio of the Aid flow (current US$) in Sierra Leone in 1996 to that in 2001?
Offer a terse response. 0.13. What is the ratio of the Aid flow (current US$) of Solomon Islands in 1996 to that in 2001?
Give a very brief answer. 0.14. What is the ratio of the Aid flow (current US$) in Ghana in 1996 to that in 2002?
Keep it short and to the point. 0.38. What is the ratio of the Aid flow (current US$) in Kenya in 1996 to that in 2002?
Your answer should be compact. 3.15. What is the ratio of the Aid flow (current US$) in Sierra Leone in 1996 to that in 2002?
Your answer should be compact. 0.24. What is the ratio of the Aid flow (current US$) in Ghana in 1996 to that in 2005?
Give a very brief answer. 0.32. What is the ratio of the Aid flow (current US$) of Kenya in 1996 to that in 2005?
Your answer should be compact. 1.41. What is the ratio of the Aid flow (current US$) of Sierra Leone in 1996 to that in 2005?
Your answer should be compact. 0.67. What is the ratio of the Aid flow (current US$) of Solomon Islands in 1996 to that in 2005?
Ensure brevity in your answer.  0. What is the ratio of the Aid flow (current US$) of Ghana in 1997 to that in 1998?
Offer a terse response. 0.8. What is the ratio of the Aid flow (current US$) of Kenya in 1997 to that in 1998?
Ensure brevity in your answer.  1.09. What is the ratio of the Aid flow (current US$) in Sierra Leone in 1997 to that in 1998?
Offer a very short reply. 0.62. What is the ratio of the Aid flow (current US$) in Solomon Islands in 1997 to that in 1998?
Provide a short and direct response. 1.54. What is the ratio of the Aid flow (current US$) of Ghana in 1997 to that in 1999?
Provide a succinct answer. 1.47. What is the ratio of the Aid flow (current US$) of Kenya in 1997 to that in 1999?
Your answer should be compact. 3.05. What is the ratio of the Aid flow (current US$) in Sierra Leone in 1997 to that in 1999?
Ensure brevity in your answer.  0.44. What is the ratio of the Aid flow (current US$) in Ghana in 1997 to that in 2001?
Provide a short and direct response. 0.15. What is the ratio of the Aid flow (current US$) in Kenya in 1997 to that in 2001?
Offer a terse response. 1.37. What is the ratio of the Aid flow (current US$) in Sierra Leone in 1997 to that in 2001?
Provide a short and direct response. 0.04. What is the ratio of the Aid flow (current US$) of Solomon Islands in 1997 to that in 2001?
Provide a succinct answer. 2.86. What is the ratio of the Aid flow (current US$) in Ghana in 1997 to that in 2002?
Provide a short and direct response. 0.29. What is the ratio of the Aid flow (current US$) of Kenya in 1997 to that in 2002?
Ensure brevity in your answer.  2.51. What is the ratio of the Aid flow (current US$) in Sierra Leone in 1997 to that in 2002?
Your answer should be very brief. 0.07. What is the ratio of the Aid flow (current US$) of Ghana in 1997 to that in 2005?
Ensure brevity in your answer.  0.25. What is the ratio of the Aid flow (current US$) in Kenya in 1997 to that in 2005?
Give a very brief answer. 1.12. What is the ratio of the Aid flow (current US$) in Solomon Islands in 1997 to that in 2005?
Your response must be concise. 0.04. What is the ratio of the Aid flow (current US$) in Ghana in 1998 to that in 1999?
Your response must be concise. 1.84. What is the ratio of the Aid flow (current US$) in Kenya in 1998 to that in 1999?
Provide a succinct answer. 2.81. What is the ratio of the Aid flow (current US$) of Sierra Leone in 1998 to that in 1999?
Keep it short and to the point. 0.72. What is the ratio of the Aid flow (current US$) of Ghana in 1998 to that in 2001?
Give a very brief answer. 0.19. What is the ratio of the Aid flow (current US$) of Kenya in 1998 to that in 2001?
Your answer should be compact. 1.26. What is the ratio of the Aid flow (current US$) in Sierra Leone in 1998 to that in 2001?
Make the answer very short. 0.06. What is the ratio of the Aid flow (current US$) in Solomon Islands in 1998 to that in 2001?
Offer a very short reply. 1.86. What is the ratio of the Aid flow (current US$) of Ghana in 1998 to that in 2002?
Ensure brevity in your answer.  0.37. What is the ratio of the Aid flow (current US$) in Kenya in 1998 to that in 2002?
Ensure brevity in your answer.  2.3. What is the ratio of the Aid flow (current US$) in Sierra Leone in 1998 to that in 2002?
Offer a terse response. 0.11. What is the ratio of the Aid flow (current US$) in Ghana in 1998 to that in 2005?
Give a very brief answer. 0.31. What is the ratio of the Aid flow (current US$) in Kenya in 1998 to that in 2005?
Your answer should be very brief. 1.03. What is the ratio of the Aid flow (current US$) in Sierra Leone in 1998 to that in 2005?
Ensure brevity in your answer.  0.33. What is the ratio of the Aid flow (current US$) in Solomon Islands in 1998 to that in 2005?
Give a very brief answer. 0.03. What is the ratio of the Aid flow (current US$) in Ghana in 1999 to that in 2001?
Give a very brief answer. 0.1. What is the ratio of the Aid flow (current US$) in Kenya in 1999 to that in 2001?
Offer a terse response. 0.45. What is the ratio of the Aid flow (current US$) in Sierra Leone in 1999 to that in 2001?
Ensure brevity in your answer.  0.09. What is the ratio of the Aid flow (current US$) in Solomon Islands in 1999 to that in 2001?
Make the answer very short. 0.57. What is the ratio of the Aid flow (current US$) in Ghana in 1999 to that in 2002?
Provide a short and direct response. 0.2. What is the ratio of the Aid flow (current US$) in Kenya in 1999 to that in 2002?
Your response must be concise. 0.82. What is the ratio of the Aid flow (current US$) of Sierra Leone in 1999 to that in 2002?
Provide a succinct answer. 0.16. What is the ratio of the Aid flow (current US$) of Ghana in 1999 to that in 2005?
Keep it short and to the point. 0.17. What is the ratio of the Aid flow (current US$) in Kenya in 1999 to that in 2005?
Your response must be concise. 0.37. What is the ratio of the Aid flow (current US$) of Sierra Leone in 1999 to that in 2005?
Your response must be concise. 0.45. What is the ratio of the Aid flow (current US$) of Solomon Islands in 1999 to that in 2005?
Make the answer very short. 0.01. What is the ratio of the Aid flow (current US$) in Ghana in 2001 to that in 2002?
Give a very brief answer. 1.92. What is the ratio of the Aid flow (current US$) in Kenya in 2001 to that in 2002?
Your answer should be very brief. 1.82. What is the ratio of the Aid flow (current US$) of Sierra Leone in 2001 to that in 2002?
Give a very brief answer. 1.85. What is the ratio of the Aid flow (current US$) in Ghana in 2001 to that in 2005?
Your answer should be very brief. 1.62. What is the ratio of the Aid flow (current US$) of Kenya in 2001 to that in 2005?
Give a very brief answer. 0.82. What is the ratio of the Aid flow (current US$) in Sierra Leone in 2001 to that in 2005?
Your response must be concise. 5.3. What is the ratio of the Aid flow (current US$) in Solomon Islands in 2001 to that in 2005?
Ensure brevity in your answer.  0.01. What is the ratio of the Aid flow (current US$) in Ghana in 2002 to that in 2005?
Offer a very short reply. 0.85. What is the ratio of the Aid flow (current US$) of Kenya in 2002 to that in 2005?
Your response must be concise. 0.45. What is the ratio of the Aid flow (current US$) of Sierra Leone in 2002 to that in 2005?
Your answer should be compact. 2.86. What is the ratio of the Aid flow (current US$) in Solomon Islands in 2002 to that in 2005?
Your answer should be compact. 0. What is the difference between the highest and the second highest Aid flow (current US$) of Ghana?
Provide a short and direct response. 4.37e+07. What is the difference between the highest and the second highest Aid flow (current US$) in Kenya?
Offer a terse response. 8.16e+06. What is the difference between the highest and the second highest Aid flow (current US$) in Sierra Leone?
Offer a terse response. 1.76e+07. What is the difference between the highest and the second highest Aid flow (current US$) in Solomon Islands?
Keep it short and to the point. 4.71e+06. What is the difference between the highest and the lowest Aid flow (current US$) of Ghana?
Ensure brevity in your answer.  1.02e+08. What is the difference between the highest and the lowest Aid flow (current US$) in Kenya?
Provide a succinct answer. 2.95e+07. What is the difference between the highest and the lowest Aid flow (current US$) in Sierra Leone?
Offer a very short reply. 3.67e+07. What is the difference between the highest and the lowest Aid flow (current US$) in Solomon Islands?
Your response must be concise. 4.90e+06. 